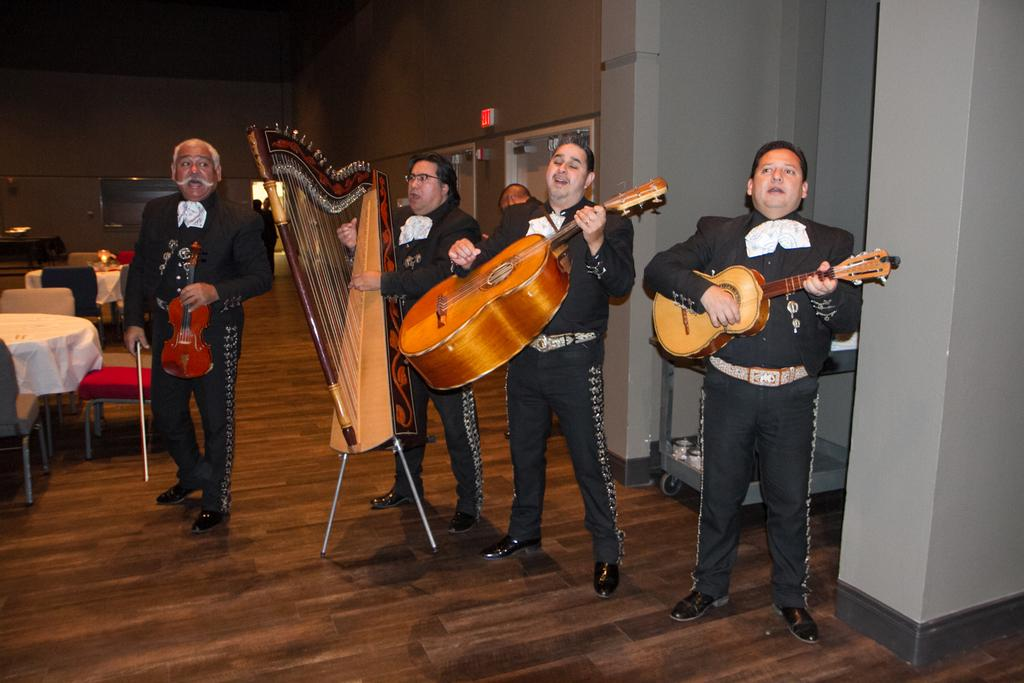How many people are in the room in the image? There are five persons in the room. What are the majority of them doing? Four of them are playing musical instruments. What furniture can be seen on the left side of the room? There are tables on the left side of the room. What type of seating is available in the room? There are chairs in the room. Can you hear the sound of a cough in the image? There is no audible sound in the image, so it is not possible to determine if a cough can be heard. What direction is the zephyr blowing in the image? There is no mention of a zephyr or any wind in the image, so it cannot be determined. 